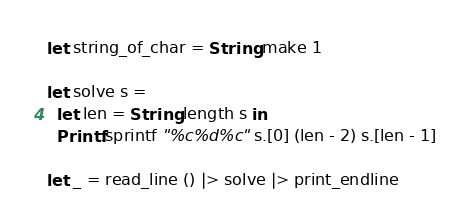<code> <loc_0><loc_0><loc_500><loc_500><_OCaml_>let string_of_char = String.make 1

let solve s =
  let len = String.length s in
  Printf.sprintf "%c%d%c" s.[0] (len - 2) s.[len - 1]

let _ = read_line () |> solve |> print_endline</code> 